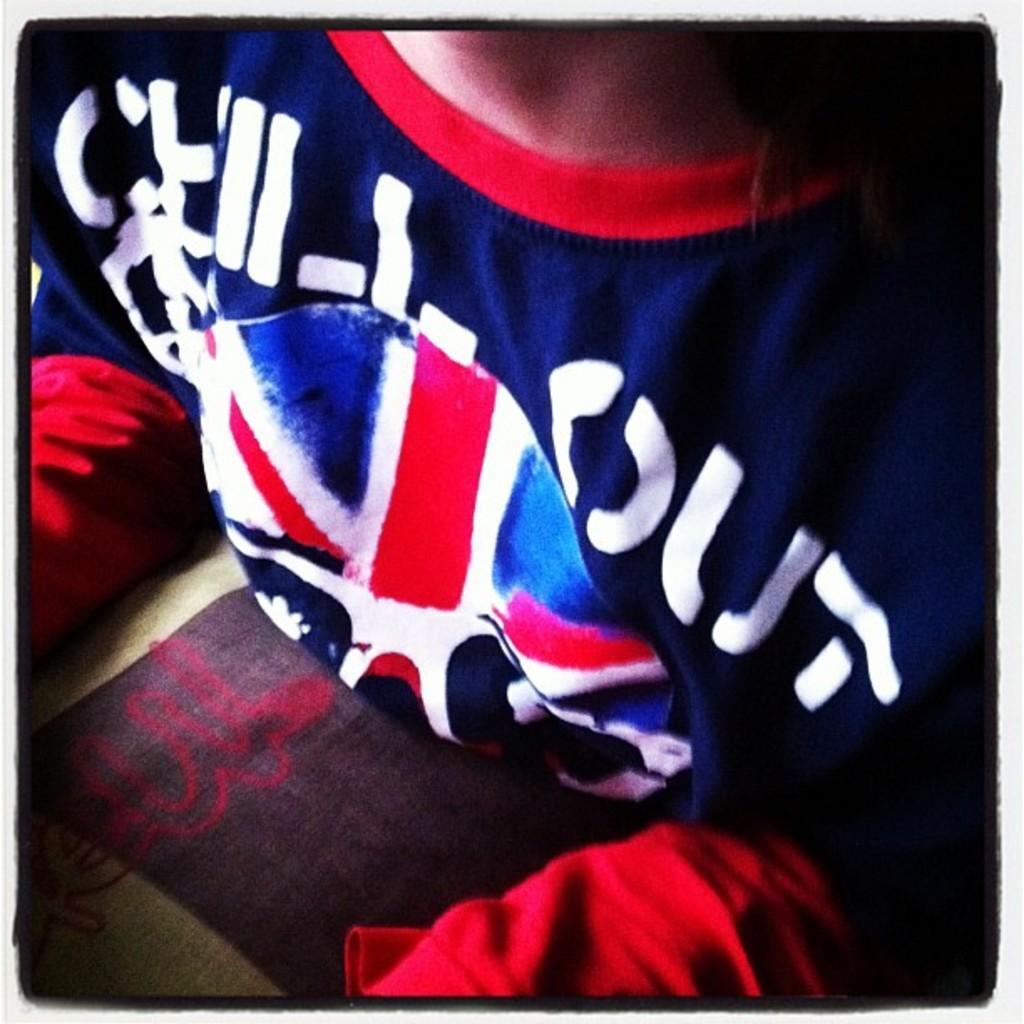<image>
Give a short and clear explanation of the subsequent image. A colourful shirt on which the word Out is visible. 